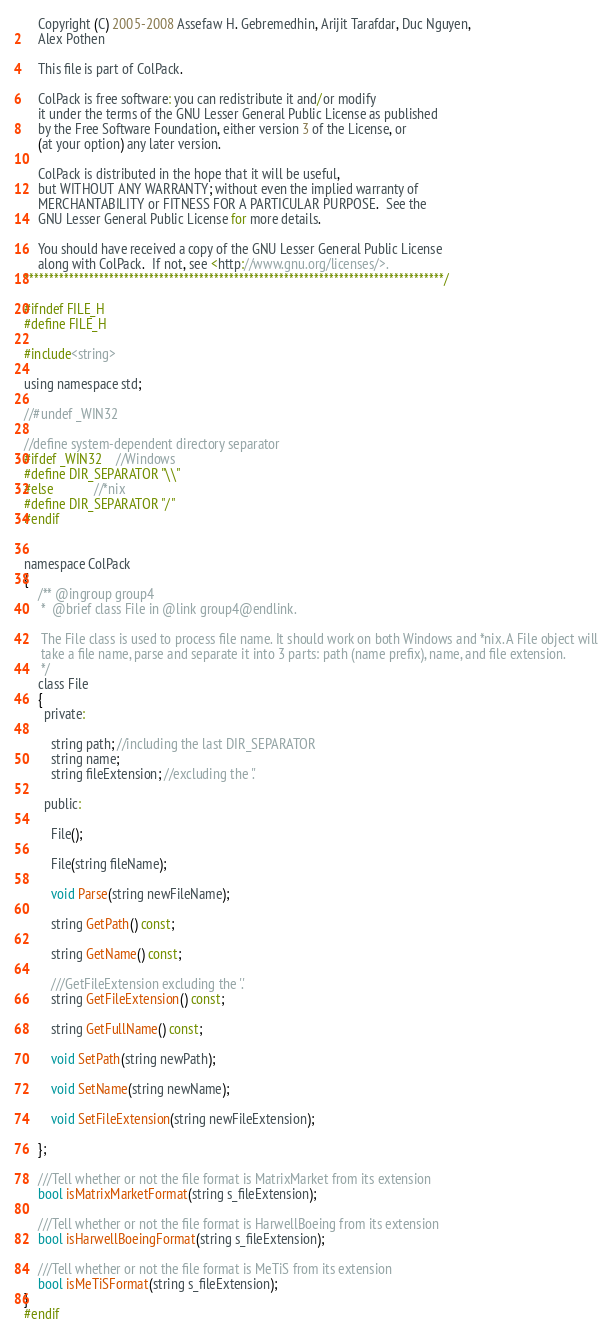<code> <loc_0><loc_0><loc_500><loc_500><_C_>    Copyright (C) 2005-2008 Assefaw H. Gebremedhin, Arijit Tarafdar, Duc Nguyen,
    Alex Pothen

    This file is part of ColPack.

    ColPack is free software: you can redistribute it and/or modify
    it under the terms of the GNU Lesser General Public License as published
    by the Free Software Foundation, either version 3 of the License, or
    (at your option) any later version.

    ColPack is distributed in the hope that it will be useful,
    but WITHOUT ANY WARRANTY; without even the implied warranty of
    MERCHANTABILITY or FITNESS FOR A PARTICULAR PURPOSE.  See the
    GNU Lesser General Public License for more details.

    You should have received a copy of the GNU Lesser General Public License
    along with ColPack.  If not, see <http://www.gnu.org/licenses/>.
************************************************************************************/

#ifndef FILE_H
#define FILE_H

#include<string>

using namespace std;

//#undef _WIN32

//define system-dependent directory separator
#ifdef _WIN32	//Windows
#define DIR_SEPARATOR "\\"
#else			//*nix
#define DIR_SEPARATOR "/"
#endif


namespace ColPack
{
	/** @ingroup group4
	 *  @brief class File in @link group4@endlink.

	 The File class is used to process file name. It should work on both Windows and *nix. A File object will
	 take a file name, parse and separate it into 3 parts: path (name prefix), name, and file extension.
	 */
	class File
	{
	  private:

		string path; //including the last DIR_SEPARATOR
		string name;
		string fileExtension; //excluding the '.'

	  public:

		File();

		File(string fileName);

		void Parse(string newFileName);

		string GetPath() const;

		string GetName() const;

		///GetFileExtension excluding the '.'
		string GetFileExtension() const;

		string GetFullName() const;

		void SetPath(string newPath);

		void SetName(string newName);

		void SetFileExtension(string newFileExtension);

	};

	///Tell whether or not the file format is MatrixMarket from its extension
	bool isMatrixMarketFormat(string s_fileExtension);

	///Tell whether or not the file format is HarwellBoeing from its extension
	bool isHarwellBoeingFormat(string s_fileExtension);

	///Tell whether or not the file format is MeTiS from its extension
	bool isMeTiSFormat(string s_fileExtension);
}
#endif
</code> 